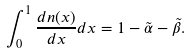<formula> <loc_0><loc_0><loc_500><loc_500>\int _ { 0 } ^ { 1 } \frac { d n ( x ) } { d x } d x = 1 - \tilde { \alpha } - \tilde { \beta } .</formula> 